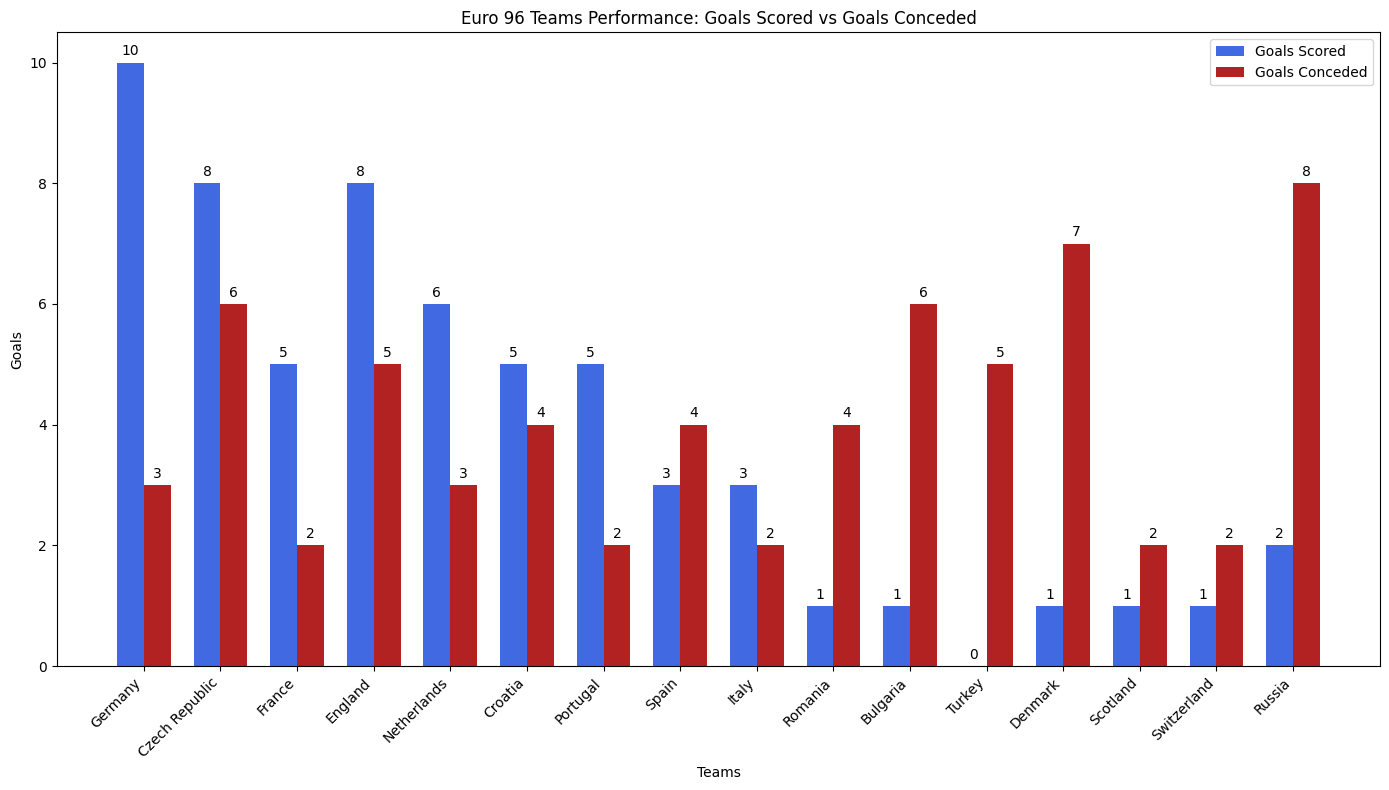Which team scored the most goals? By observing the heights of the blue bars representing 'Goals Scored', the tallest bar belongs to Germany with a height of 10 goals
Answer: Germany Which team conceded the most goals? By observing the heights of the red bars representing 'Goals Conceded', the tallest bar belongs to Russia with a height of 8 goals
Answer: Russia How many teams scored more goals than they conceded? Count the number of teams where the blue bar (Goals Scored) is taller than the red bar (Goals Conceded). These teams are Germany, France, Netherlands, Portugal, Italy, and Scotland
Answer: 6 Did any team score the same number of goals that they conceded? Look at each team to determine if their blue bar (Goals Scored) is equal in height to their red bar (Goals Conceded). No bars meet this criteria
Answer: No Which team has the most balanced goals scored and goals conceded? Balance can be interpreted as having the smallest difference between goals scored and goals conceded. The smallest differences are observed for France (3 goals difference), Portugal (3 goals difference), Italy (1 goal difference), Scotland (1 goal difference), and Switzerland (1 goal difference).
Answer: Italy, Scotland, Switzerland Which teams scored at least 5 goals but conceded fewer than 5 goals? Identify teams where the blue bar is greater than or equal to 5 and the red bar is less than 5. These teams are Germany, France, Netherlands, and Portugal
Answer: Germany, France, Netherlands, Portugal What is the total number of goals scored by all teams? Add up the heights of all the blue bars representing 'Goals Scored'. The sum is 10+8+5+8+6+5+5+3+3+1+1+0+1+1+1+2 = 59
Answer: 59 Compare the goals conceded by England and Spain. Which team conceded more? Find England and Spain, then compare the heights of their red bars. England's bar is taller at 5 goals conceded compared to Spain's 4 goals conceded
Answer: England How many teams scored fewer than 3 goals? Count the number of teams where the blue bar (Goals Scored) is less than 3. These teams are Romania, Bulgaria, Turkey, Denmark, Scotland, Switzerland, and Russia
Answer: 7 What is the difference in goals scored between the top-scoring team and the lowest-scoring team? Subtract the height of the shortest blue bar from the height of the tallest blue bar. The tallest is Germany with 10 goals, and the shortest is Turkey with 0 goals. The difference is 10 - 0 = 10
Answer: 10 